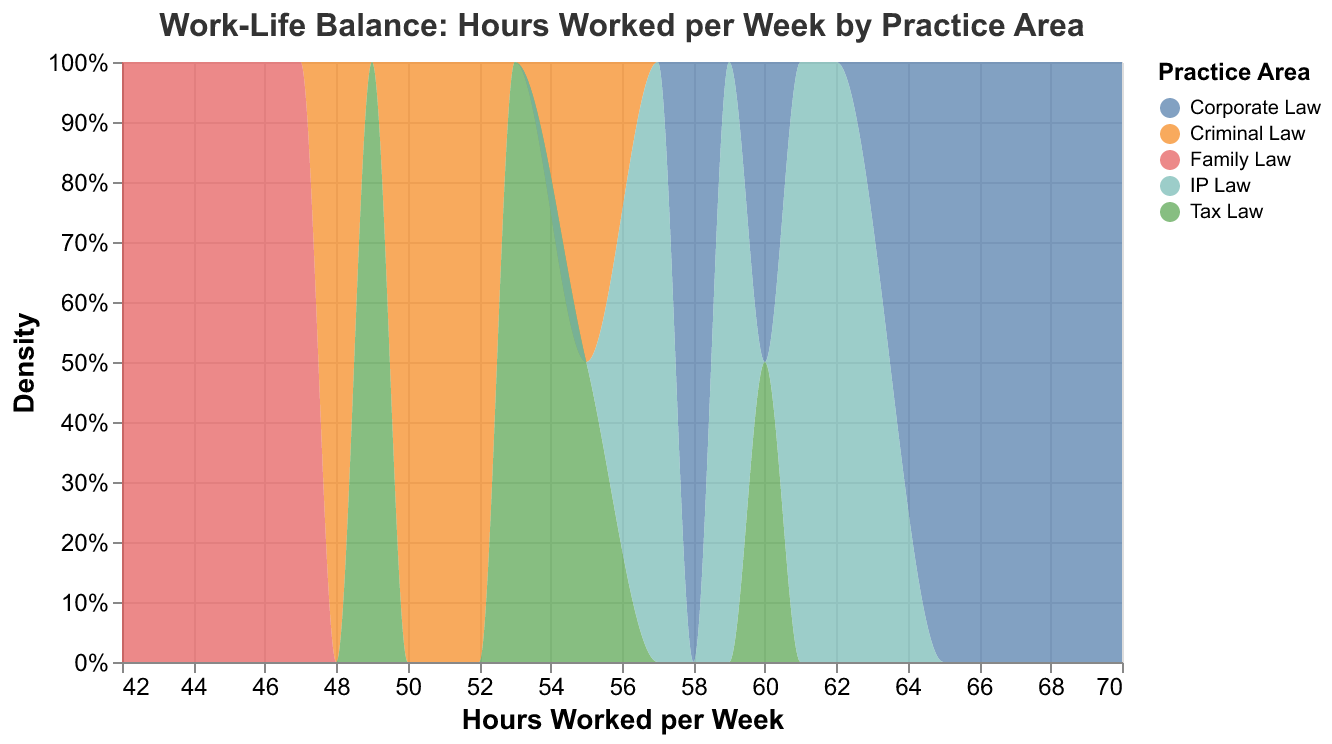What is the title of the figure? The title is usually located at the top of the figure and indicates the main subject being visualized. In this case, the title is provided at the top.
Answer: Work-Life Balance: Hours Worked per Week by Practice Area How many practice areas are represented in the plot? The different colors in the plot represent various practice areas. By identifying and counting these unique colors, we can determine the number of practice areas.
Answer: 5 Which practice area has the highest peak in the density plot? The practice area with the highest peak will have the tallest section in the density plot. This peak represents the mode of the distribution for that practice area.
Answer: Corporate Law What is the range of hours worked per week for Family Law partners? The range can be determined by observing the boundaries of the density plot for Family Law, which are the minimum and maximum values on the x-axis.
Answer: 42 to 47 hours Are there any overlaps in hours worked per week between different practice areas? To determine overlaps, we need to identify areas on the x-axis where density plots for different practice areas coincide.
Answer: Yes Which practice area has the narrowest range of hours worked per week? The narrowest range can be identified by looking for the practice area whose density plot is confined to the smallest interval on the x-axis.
Answer: Family Law How do the working hours of Tax Law compare to those of Criminal Law? By examining the density plots for both Tax Law and Criminal Law, compare their positions and distributions along the x-axis.
Answer: Tax Law partners generally work more hours per week than Criminal Law partners What is the approximate median number of hours worked per week for IP Law partners? The median represents the middle value in a distribution. For IP Law, find the point on the x-axis where the area under the density curve is equally divided.
Answer: Approximately 59 hours Which practice area shows the greatest variation in hours worked per week? The greatest variation can be identified by looking for the practice area with the widest spread on the x-axis (farthest apart minimum and maximum values).
Answer: Corporate Law 